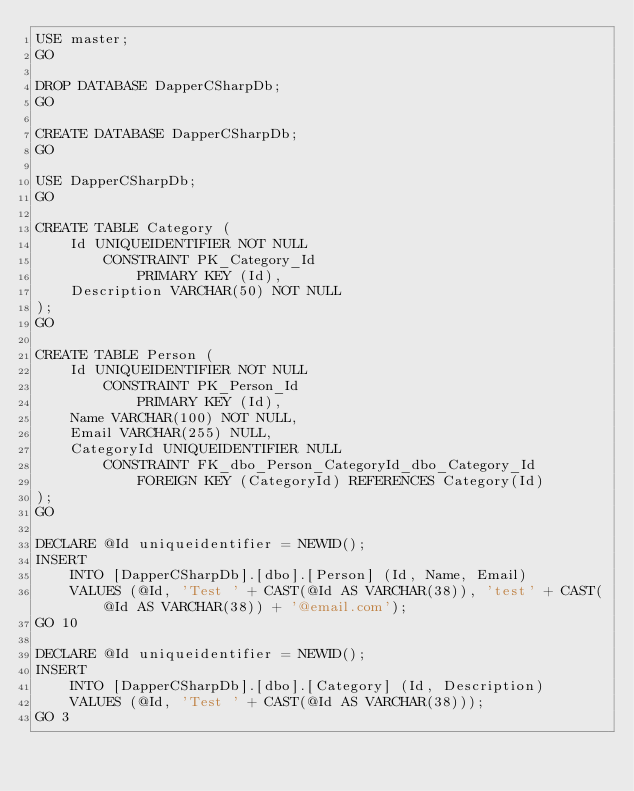<code> <loc_0><loc_0><loc_500><loc_500><_SQL_>USE master;
GO

DROP DATABASE DapperCSharpDb;
GO

CREATE DATABASE DapperCSharpDb;
GO

USE DapperCSharpDb;
GO

CREATE TABLE Category (
    Id UNIQUEIDENTIFIER NOT NULL
        CONSTRAINT PK_Category_Id
            PRIMARY KEY (Id),
    Description VARCHAR(50) NOT NULL
);
GO

CREATE TABLE Person (
    Id UNIQUEIDENTIFIER NOT NULL
        CONSTRAINT PK_Person_Id
            PRIMARY KEY (Id),
    Name VARCHAR(100) NOT NULL,    
    Email VARCHAR(255) NULL,
    CategoryId UNIQUEIDENTIFIER NULL
        CONSTRAINT FK_dbo_Person_CategoryId_dbo_Category_Id
            FOREIGN KEY (CategoryId) REFERENCES Category(Id)
);
GO

DECLARE @Id uniqueidentifier = NEWID();
INSERT 
    INTO [DapperCSharpDb].[dbo].[Person] (Id, Name, Email)
    VALUES (@Id, 'Test ' + CAST(@Id AS VARCHAR(38)), 'test' + CAST(@Id AS VARCHAR(38)) + '@email.com');
GO 10

DECLARE @Id uniqueidentifier = NEWID();
INSERT 
    INTO [DapperCSharpDb].[dbo].[Category] (Id, Description)
    VALUES (@Id, 'Test ' + CAST(@Id AS VARCHAR(38)));
GO 3</code> 